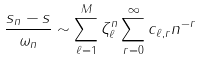Convert formula to latex. <formula><loc_0><loc_0><loc_500><loc_500>\frac { s _ { n } - s } { \omega _ { n } } \sim \sum _ { \ell = 1 } ^ { M } \zeta _ { \ell } ^ { n } \sum _ { r = 0 } ^ { \infty } c _ { \ell , r } n ^ { - r }</formula> 